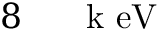Convert formula to latex. <formula><loc_0><loc_0><loc_500><loc_500>8 { { \, } } { \mathrm { k } \ e V }</formula> 